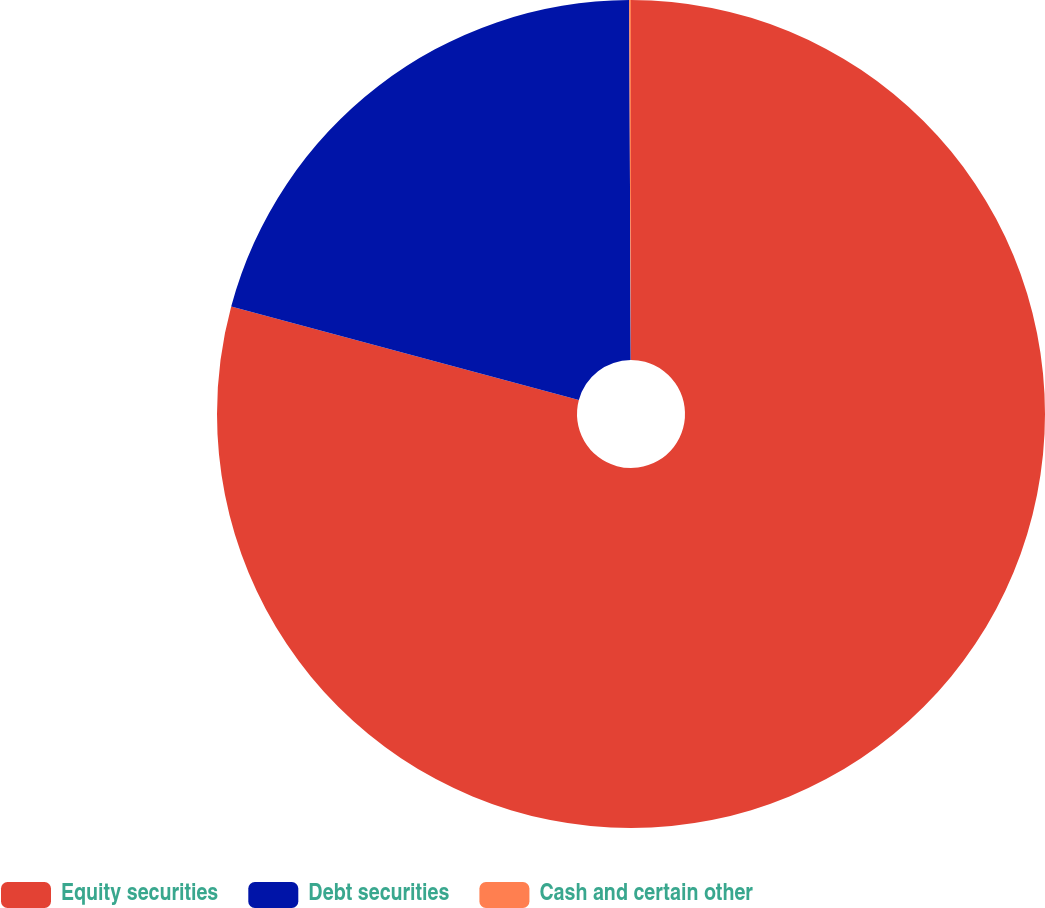Convert chart to OTSL. <chart><loc_0><loc_0><loc_500><loc_500><pie_chart><fcel>Equity securities<fcel>Debt securities<fcel>Cash and certain other<nl><fcel>79.18%<fcel>20.75%<fcel>0.07%<nl></chart> 